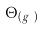Convert formula to latex. <formula><loc_0><loc_0><loc_500><loc_500>\Theta _ { ( g _ { u } ) }</formula> 